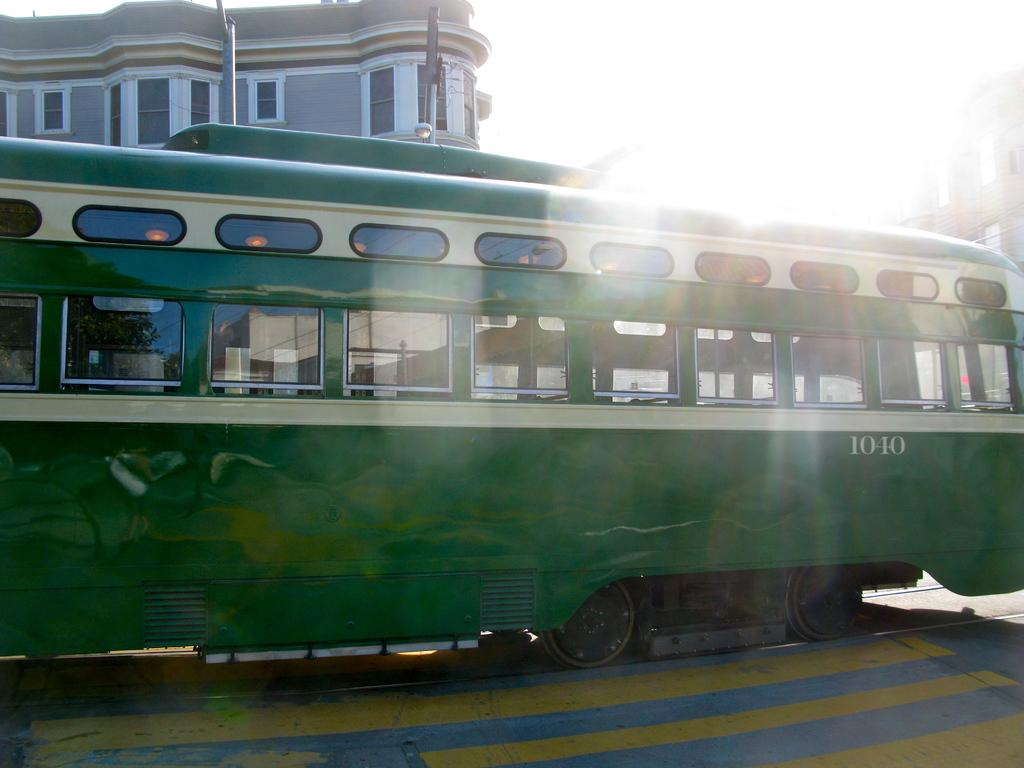<image>
Give a short and clear explanation of the subsequent image. the side of a green trolly that has the number 1040 on it 